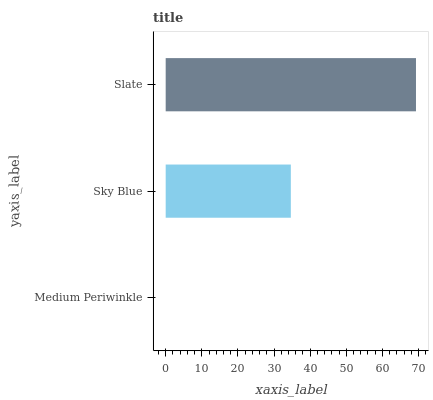Is Medium Periwinkle the minimum?
Answer yes or no. Yes. Is Slate the maximum?
Answer yes or no. Yes. Is Sky Blue the minimum?
Answer yes or no. No. Is Sky Blue the maximum?
Answer yes or no. No. Is Sky Blue greater than Medium Periwinkle?
Answer yes or no. Yes. Is Medium Periwinkle less than Sky Blue?
Answer yes or no. Yes. Is Medium Periwinkle greater than Sky Blue?
Answer yes or no. No. Is Sky Blue less than Medium Periwinkle?
Answer yes or no. No. Is Sky Blue the high median?
Answer yes or no. Yes. Is Sky Blue the low median?
Answer yes or no. Yes. Is Medium Periwinkle the high median?
Answer yes or no. No. Is Slate the low median?
Answer yes or no. No. 